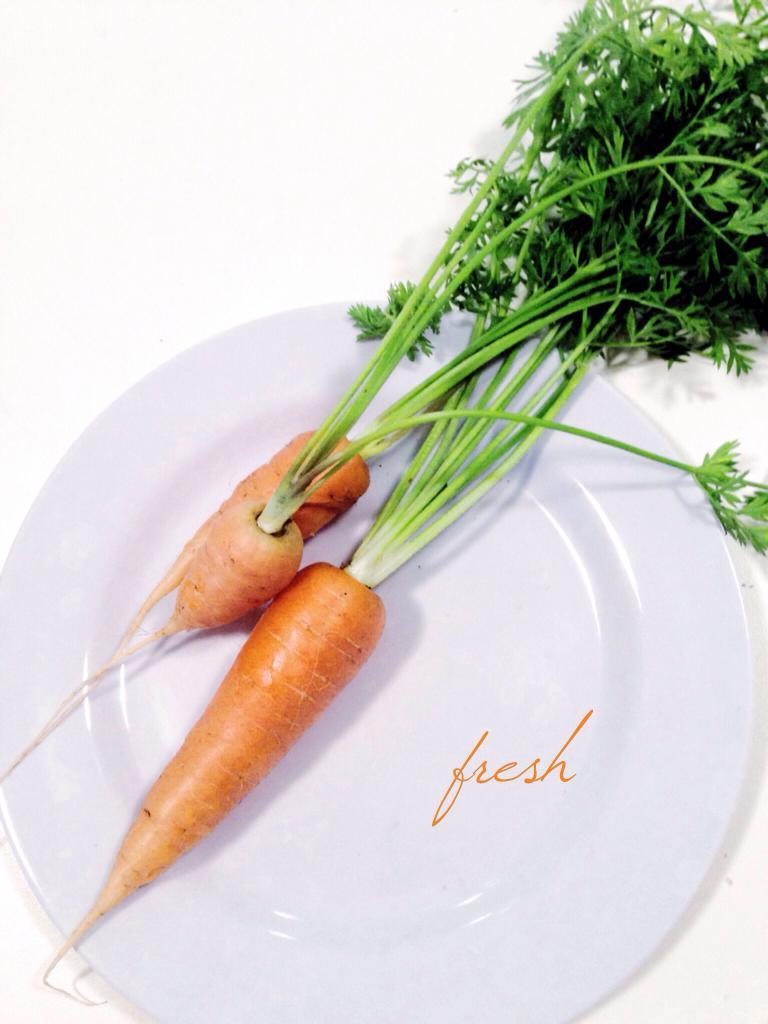What object is present on the plate in the image? There is a plate in the image. What is on top of the plate? There are two carrots and green leaves on the plate. What time of day is it in the image? The time of day is not mentioned or depicted in the image. What type of lettuce is present on the plate? There is no lettuce present on the plate; it has green leaves, but they are not specified as lettuce. 